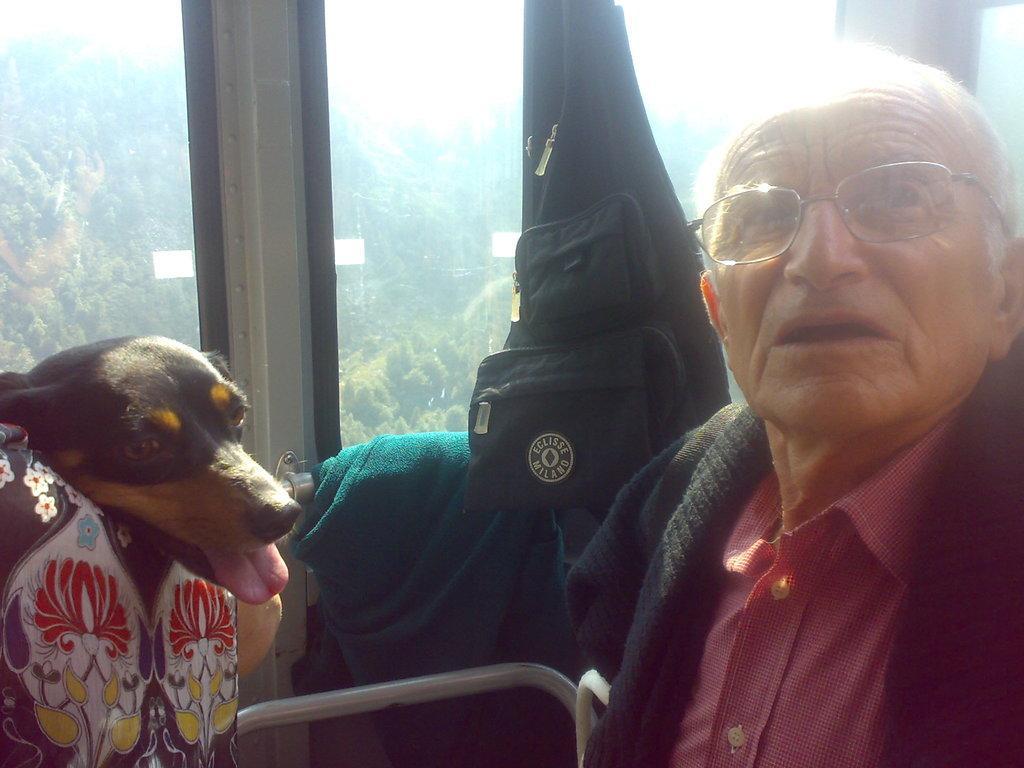How would you summarize this image in a sentence or two? In the image we can see there is a man who is wearing a red colour shirt and black colour sweater. Beside him there is a dog who is in cream and black colour. In between them there is a black colour bag and on the other side of the window there are lot of trees. 